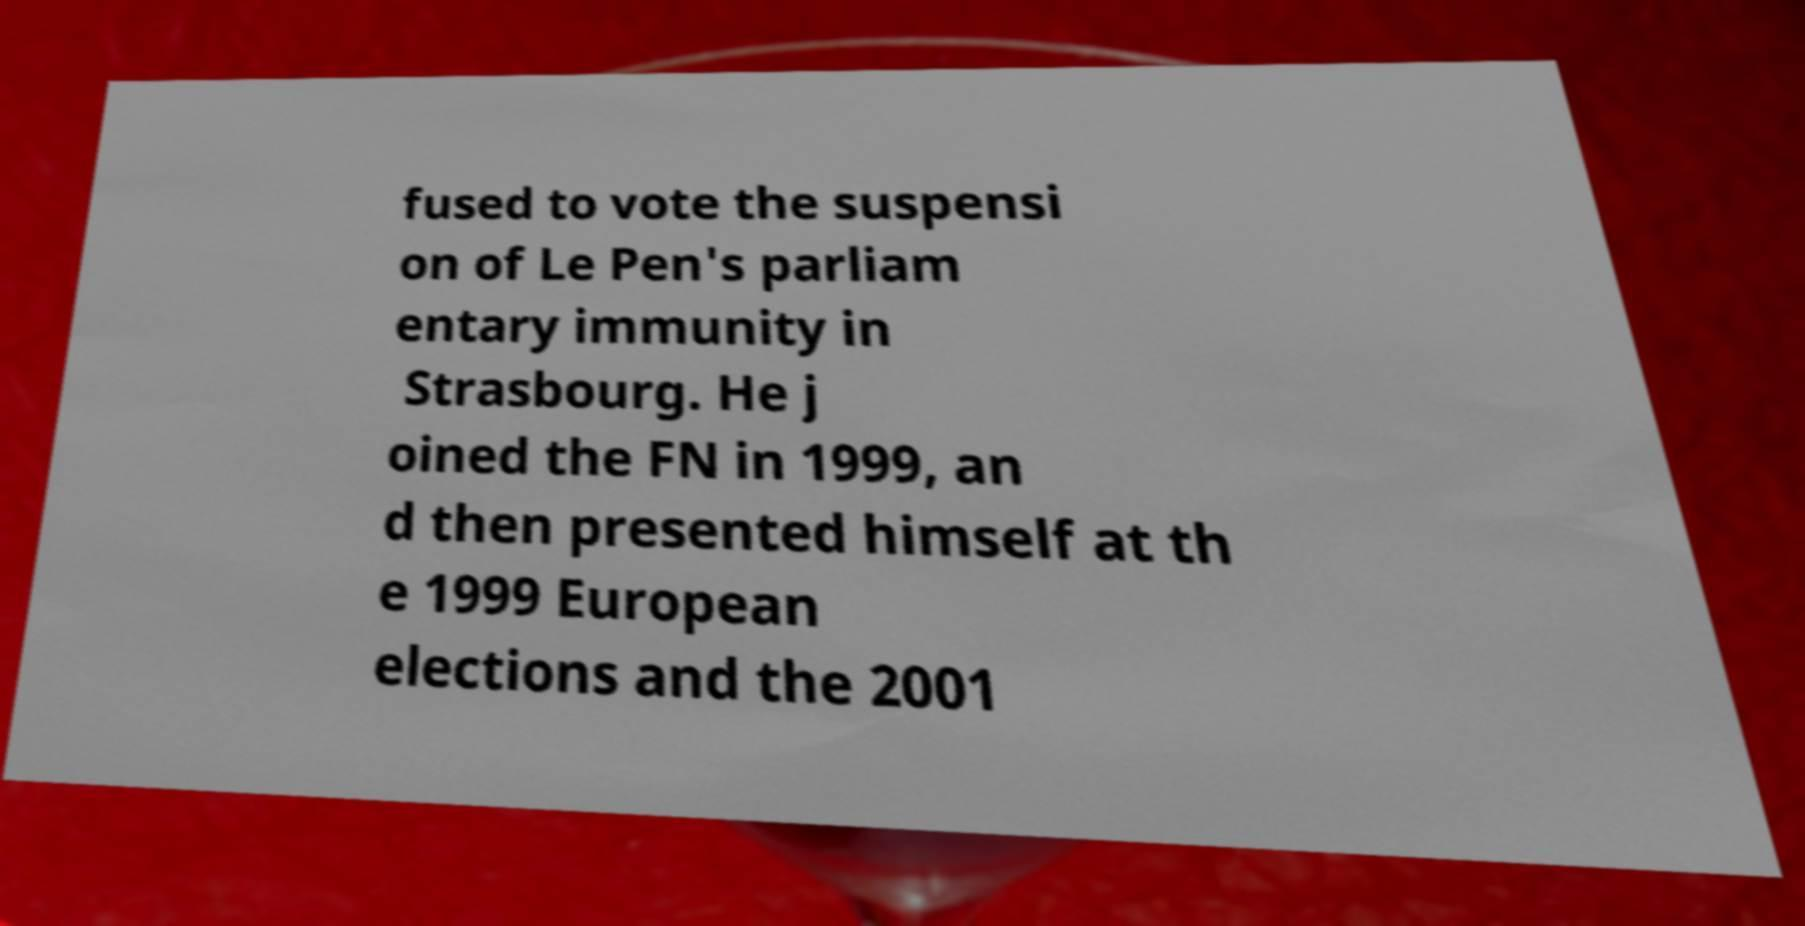I need the written content from this picture converted into text. Can you do that? fused to vote the suspensi on of Le Pen's parliam entary immunity in Strasbourg. He j oined the FN in 1999, an d then presented himself at th e 1999 European elections and the 2001 